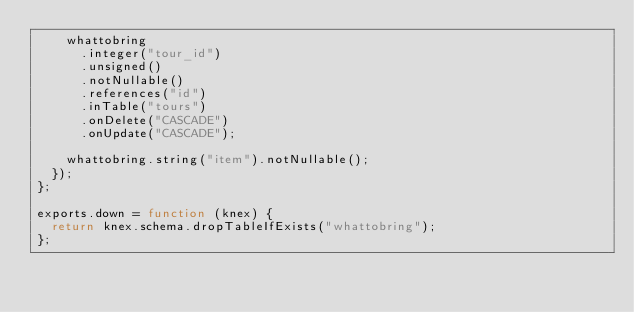Convert code to text. <code><loc_0><loc_0><loc_500><loc_500><_JavaScript_>    whattobring
      .integer("tour_id")
      .unsigned()
      .notNullable()
      .references("id")
      .inTable("tours")
      .onDelete("CASCADE")
      .onUpdate("CASCADE");

    whattobring.string("item").notNullable();
  });
};

exports.down = function (knex) {
  return knex.schema.dropTableIfExists("whattobring");
};
</code> 